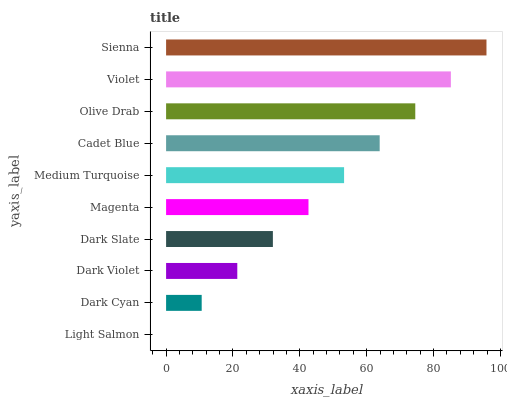Is Light Salmon the minimum?
Answer yes or no. Yes. Is Sienna the maximum?
Answer yes or no. Yes. Is Dark Cyan the minimum?
Answer yes or no. No. Is Dark Cyan the maximum?
Answer yes or no. No. Is Dark Cyan greater than Light Salmon?
Answer yes or no. Yes. Is Light Salmon less than Dark Cyan?
Answer yes or no. Yes. Is Light Salmon greater than Dark Cyan?
Answer yes or no. No. Is Dark Cyan less than Light Salmon?
Answer yes or no. No. Is Medium Turquoise the high median?
Answer yes or no. Yes. Is Magenta the low median?
Answer yes or no. Yes. Is Dark Cyan the high median?
Answer yes or no. No. Is Light Salmon the low median?
Answer yes or no. No. 